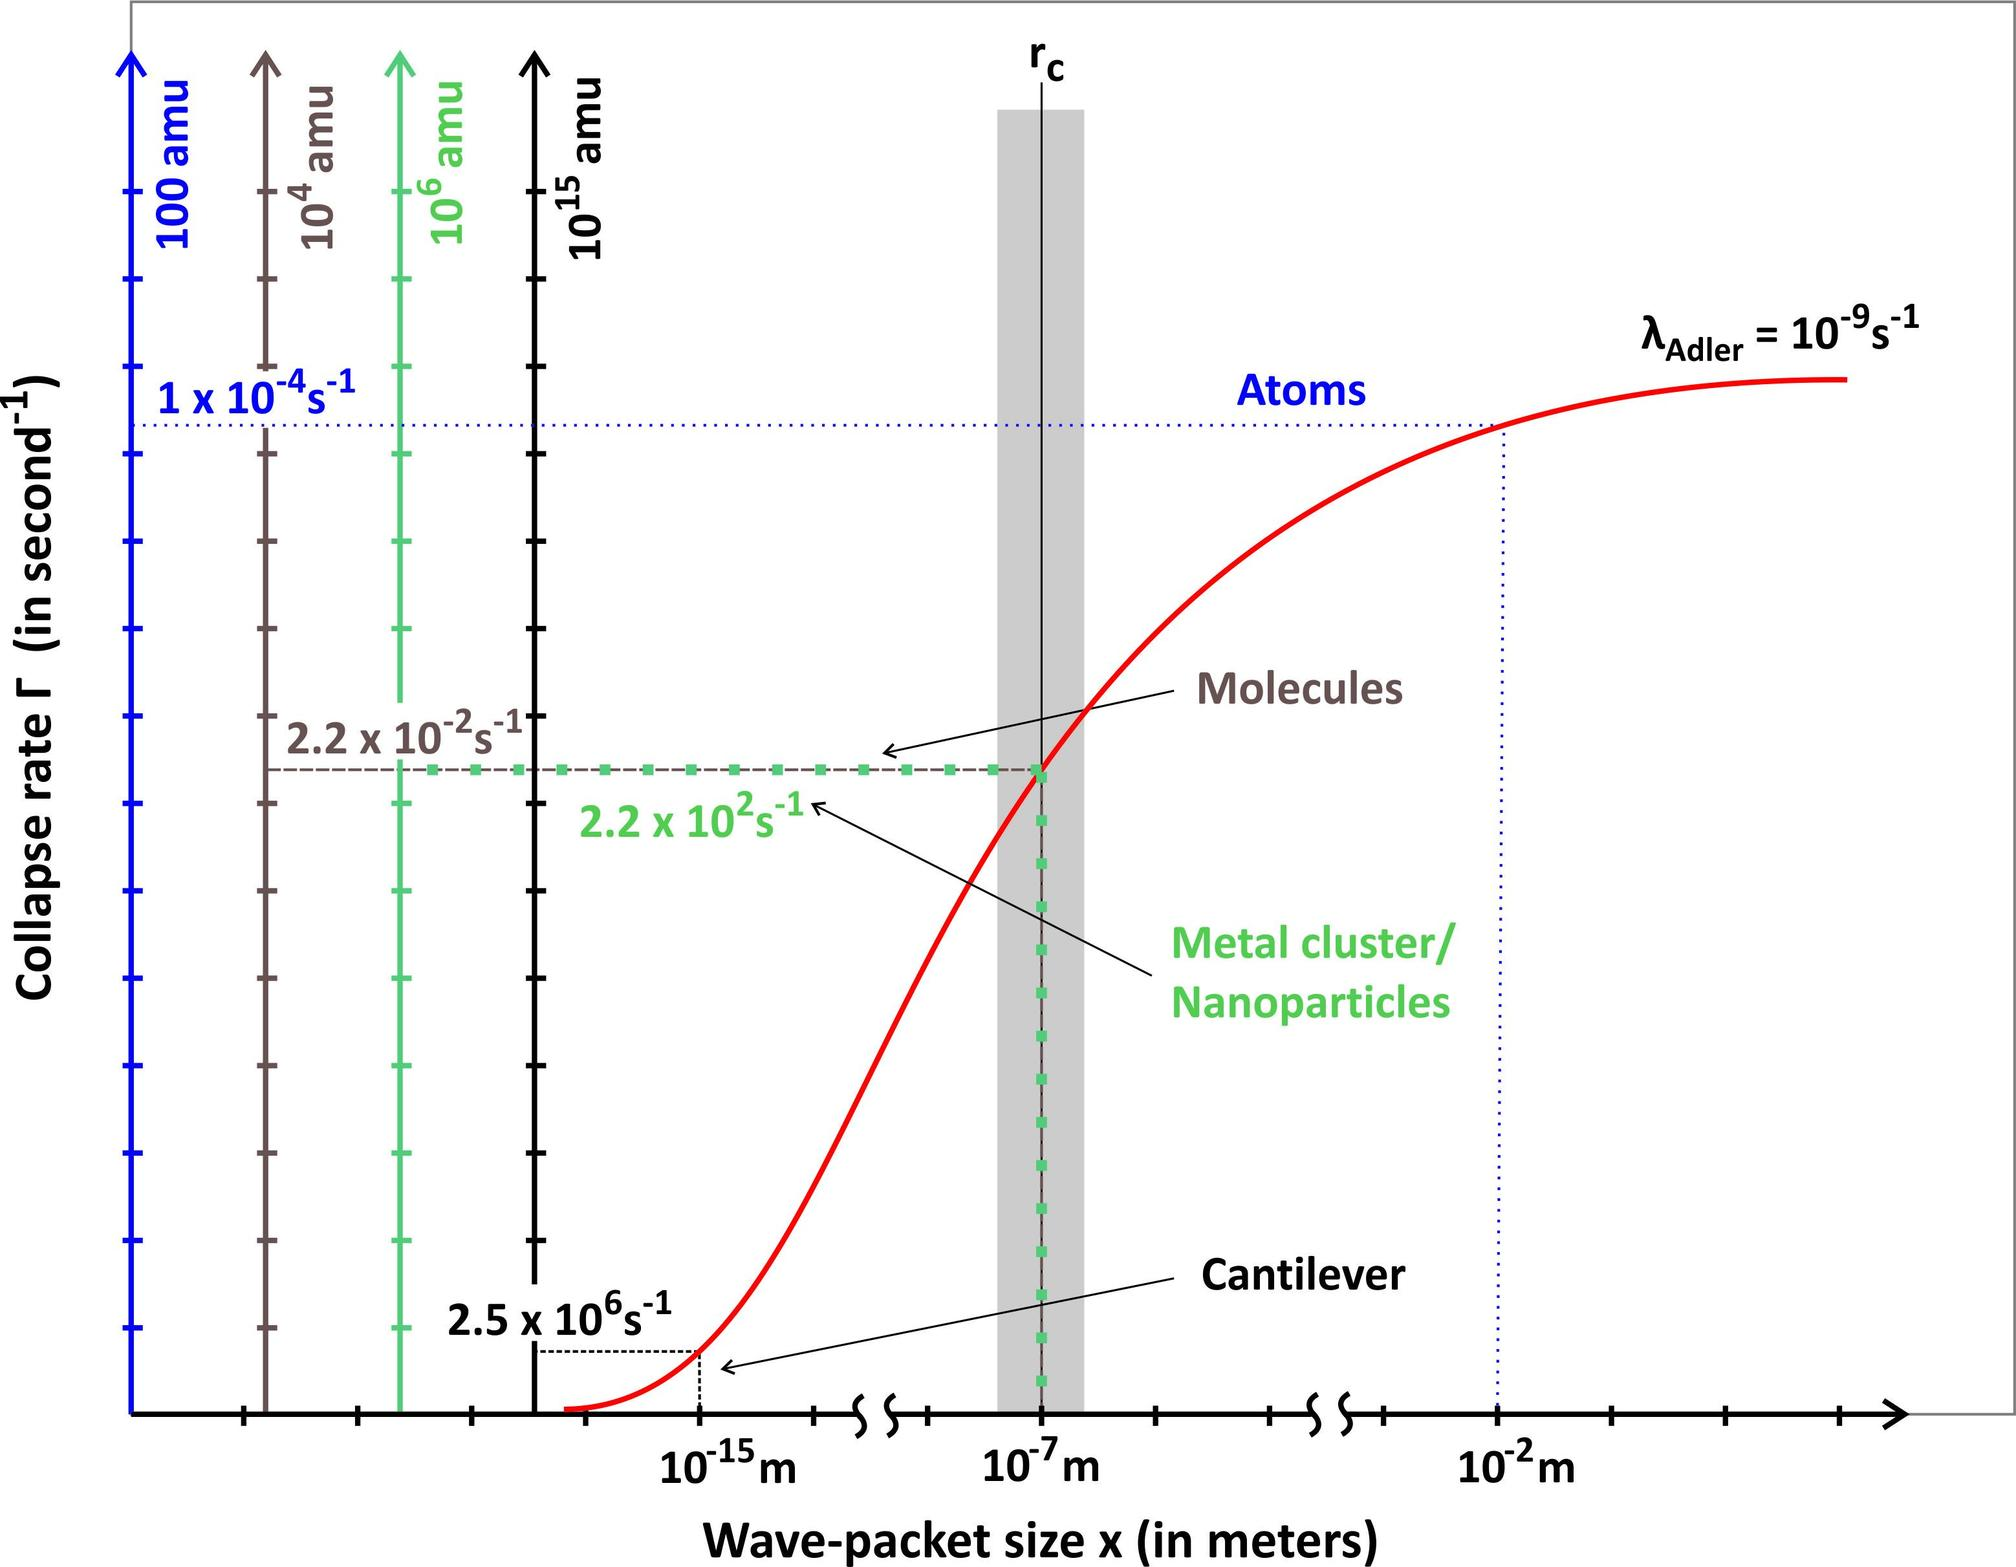Can this graph provide insights on the limitations of certain physical theories? Absolutely, this graph could be a tool to explore the limitations of classical physics in describing quantum events. The different regions marked by the phase boundaries indicate areas where classical physics might not provide accurate predictions and where quantum mechanics becomes necessary to understand the observed behavior. This illustrates the need for theories that effectively bridge these gaps, especially in the context of nano-scale and quantum phenomena. 